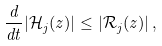Convert formula to latex. <formula><loc_0><loc_0><loc_500><loc_500>\frac { d } { d t } | \mathcal { H } _ { j } ( z ) | \leq | \mathcal { R } _ { j } ( z ) | \, ,</formula> 